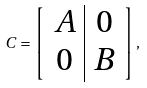Convert formula to latex. <formula><loc_0><loc_0><loc_500><loc_500>C = \left [ \begin{array} { c | c } A & 0 \\ 0 & B \end{array} \right ] ,</formula> 